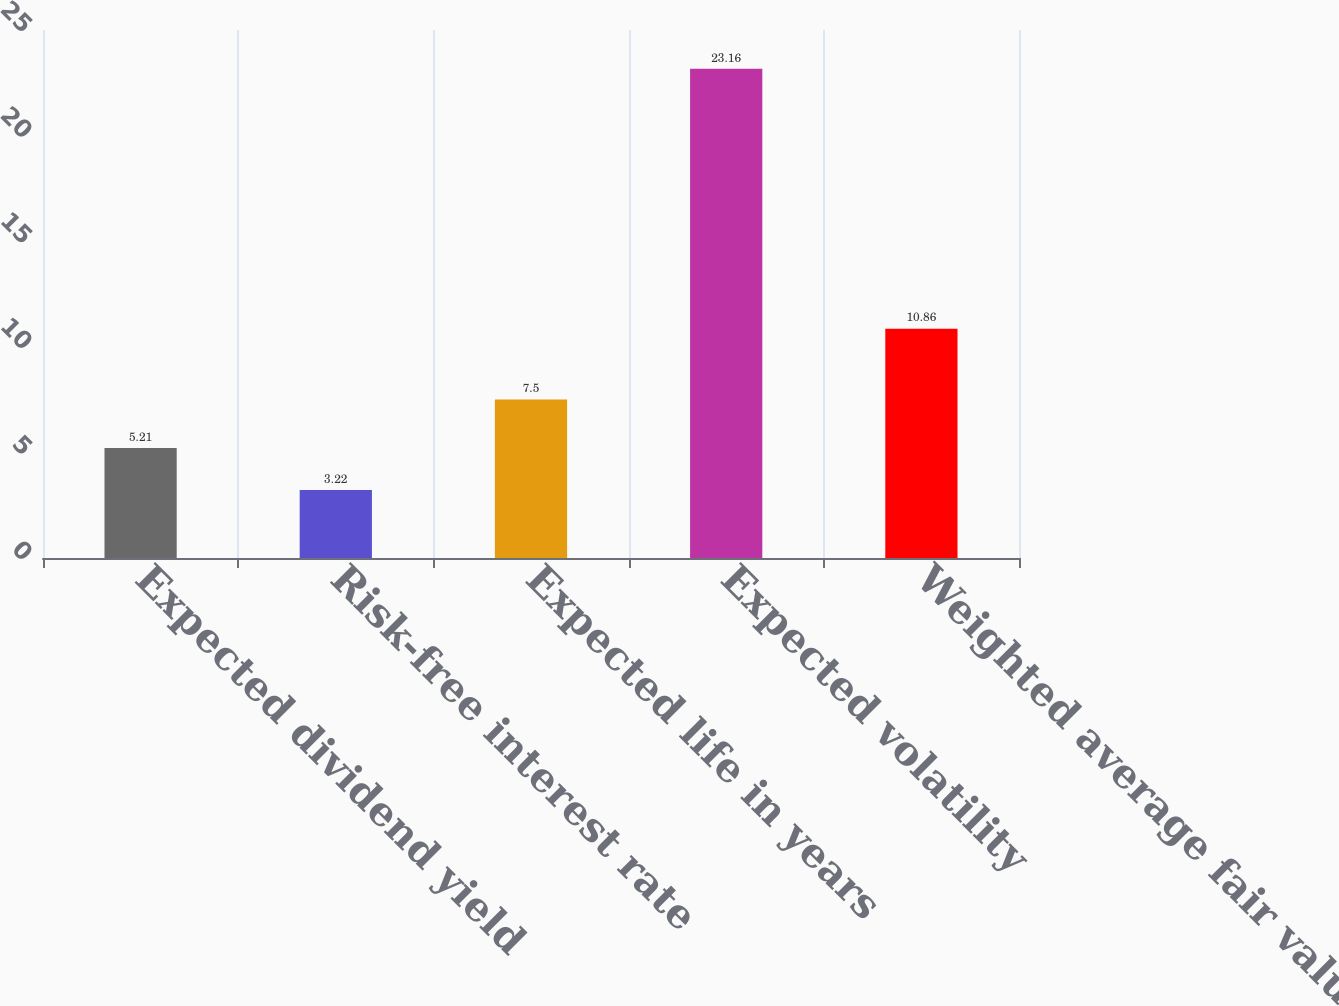Convert chart. <chart><loc_0><loc_0><loc_500><loc_500><bar_chart><fcel>Expected dividend yield<fcel>Risk-free interest rate<fcel>Expected life in years<fcel>Expected volatility<fcel>Weighted average fair value of<nl><fcel>5.21<fcel>3.22<fcel>7.5<fcel>23.16<fcel>10.86<nl></chart> 